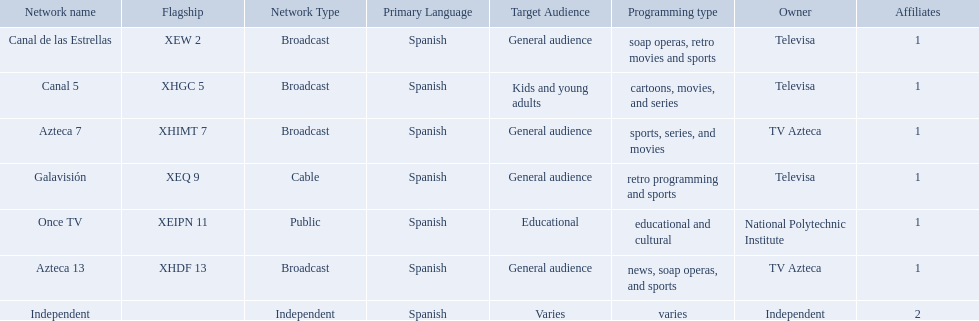What are each of the networks? Canal de las Estrellas, Canal 5, Azteca 7, Galavisión, Once TV, Azteca 13, Independent. Who owns them? Televisa, Televisa, TV Azteca, Televisa, National Polytechnic Institute, TV Azteca, Independent. Which networks aren't owned by televisa? Azteca 7, Once TV, Azteca 13, Independent. What type of programming do those networks offer? Sports, series, and movies, educational and cultural, news, soap operas, and sports, varies. And which network is the only one with sports? Azteca 7. What station shows cartoons? Canal 5. What station shows soap operas? Canal de las Estrellas. What station shows sports? Azteca 7. What television stations are in morelos? Canal de las Estrellas, Canal 5, Azteca 7, Galavisión, Once TV, Azteca 13, Independent. Of those which network is owned by national polytechnic institute? Once TV. Which owner only owns one network? National Polytechnic Institute, Independent. Of those, what is the network name? Once TV, Independent. Of those, which programming type is educational and cultural? Once TV. Who are the owners of the stations listed here? Televisa, Televisa, TV Azteca, Televisa, National Polytechnic Institute, TV Azteca, Independent. Help me parse the entirety of this table. {'header': ['Network name', 'Flagship', 'Network Type', 'Primary Language', 'Target Audience', 'Programming type', 'Owner', 'Affiliates'], 'rows': [['Canal de las Estrellas', 'XEW 2', 'Broadcast', 'Spanish', 'General audience', 'soap operas, retro movies and sports', 'Televisa', '1'], ['Canal 5', 'XHGC 5', 'Broadcast', 'Spanish', 'Kids and young adults', 'cartoons, movies, and series', 'Televisa', '1'], ['Azteca 7', 'XHIMT 7', 'Broadcast', 'Spanish', 'General audience', 'sports, series, and movies', 'TV Azteca', '1'], ['Galavisión', 'XEQ 9', 'Cable', 'Spanish', 'General audience', 'retro programming and sports', 'Televisa', '1'], ['Once TV', 'XEIPN 11', 'Public', 'Spanish', 'Educational', 'educational and cultural', 'National Polytechnic Institute', '1'], ['Azteca 13', 'XHDF 13', 'Broadcast', 'Spanish', 'General audience', 'news, soap operas, and sports', 'TV Azteca', '1'], ['Independent', '', 'Independent', 'Spanish', 'Varies', 'varies', 'Independent', '2']]} What is the one station owned by national polytechnic institute? Once TV. 